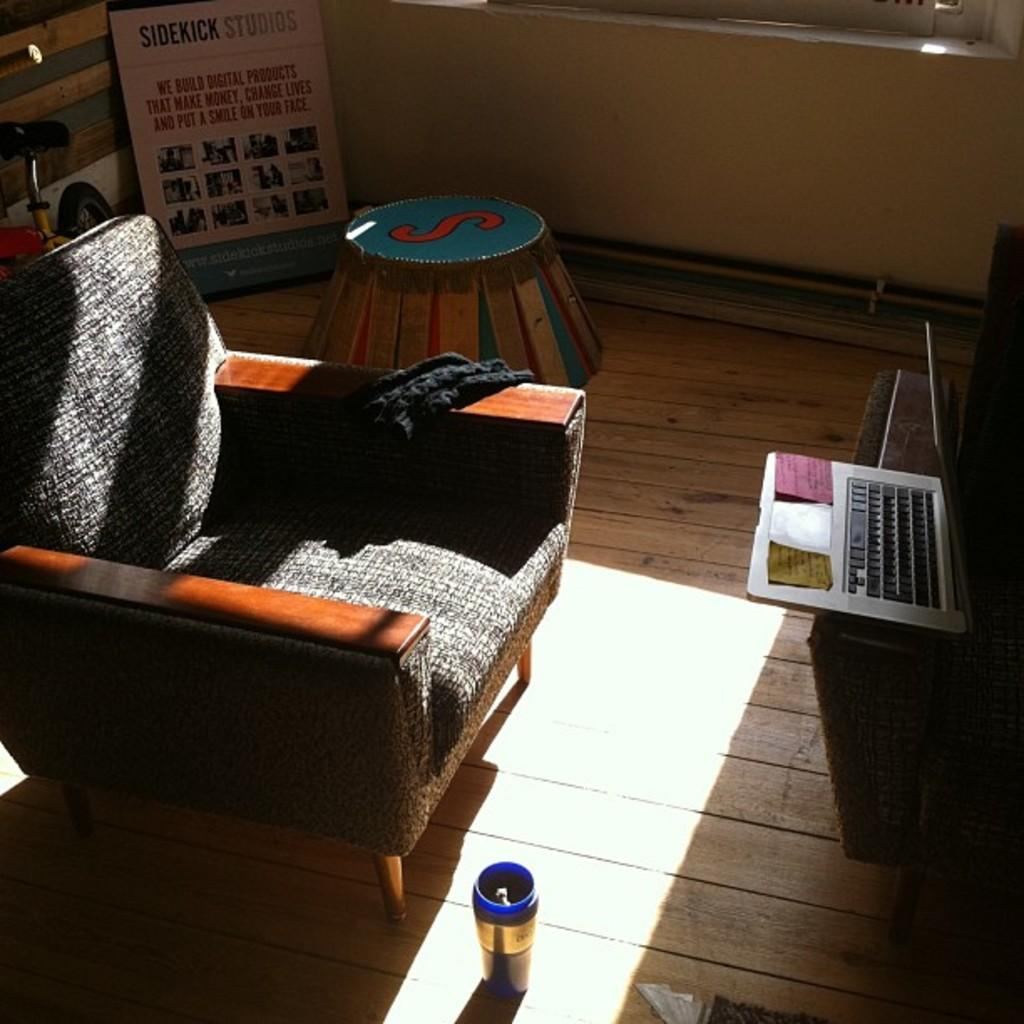What type of furniture is present in the room? There is a chair in the room. What electronic device can be seen on a table in the room? There is a laptop on a table in the room. What mode of transportation is present in the room? There is a bicycle in the room. How many buns are on the bicycle in the image? There are no buns present in the image; it features a chair, a laptop, and a bicycle. How long does it take for the laptop to complete a task in the image? The image does not provide information about the laptop's performance or the time it takes to complete a task. 